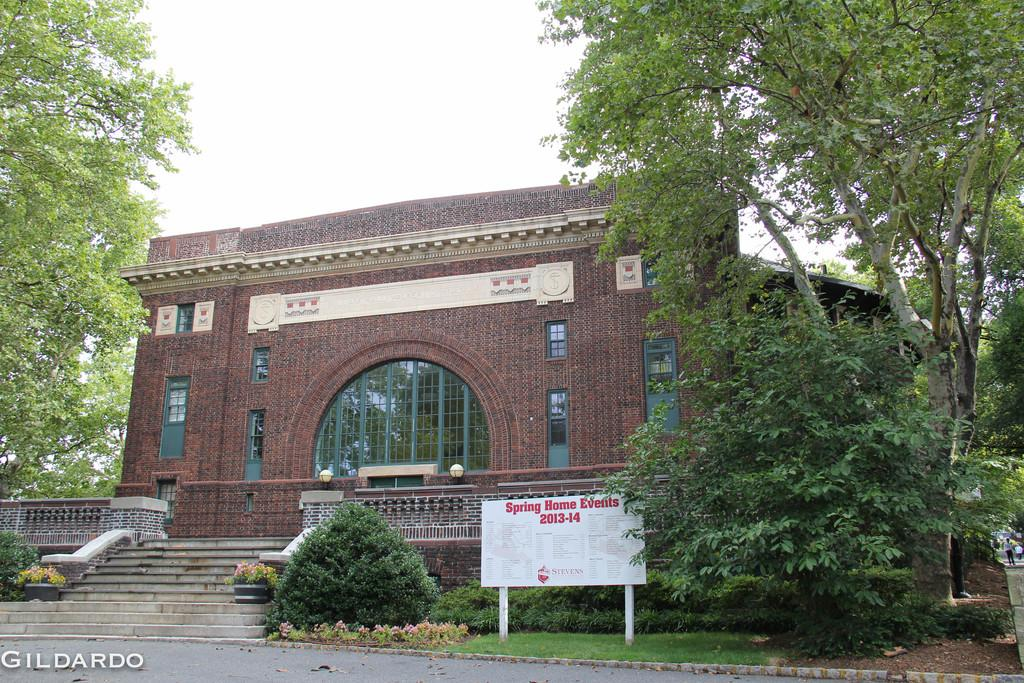What is the main feature of the image? There is a road in the image. What is located beside the road? There is a name board beside the road. What type of plants can be seen in the image? House plants and trees are visible in the image. Are there any structures in the image? Yes, there is a building in the image. Who or what is present in the image? People are present in the image. What can be seen in the background of the image? The sky is visible in the background of the image. What type of metal rings are visible on the trees in the image? There are no metal rings visible on the trees in the image. 